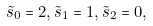Convert formula to latex. <formula><loc_0><loc_0><loc_500><loc_500>\tilde { s } _ { 0 } = 2 , \tilde { s } _ { 1 } = 1 , \tilde { s } _ { 2 } = 0 ,</formula> 